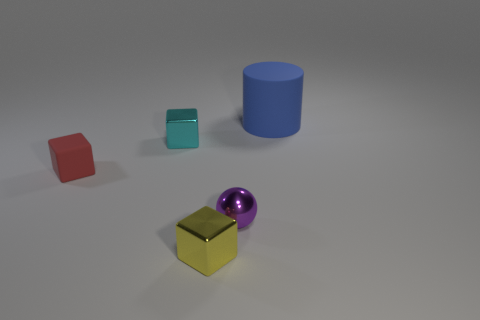What material is the block that is on the left side of the tiny metal block that is behind the ball?
Make the answer very short. Rubber. The purple metal thing is what shape?
Your answer should be compact. Sphere. There is a tiny yellow object that is the same shape as the cyan metallic object; what is it made of?
Offer a very short reply. Metal. How many spheres have the same size as the cylinder?
Offer a very short reply. 0. There is a small cube in front of the sphere; are there any tiny shiny spheres that are in front of it?
Keep it short and to the point. No. How many brown objects are small matte spheres or cylinders?
Ensure brevity in your answer.  0. What color is the big matte cylinder?
Your response must be concise. Blue. What is the size of the cyan cube that is made of the same material as the sphere?
Your answer should be very brief. Small. What number of other small objects have the same shape as the cyan thing?
Offer a terse response. 2. Are there any other things that are the same size as the red object?
Offer a very short reply. Yes. 